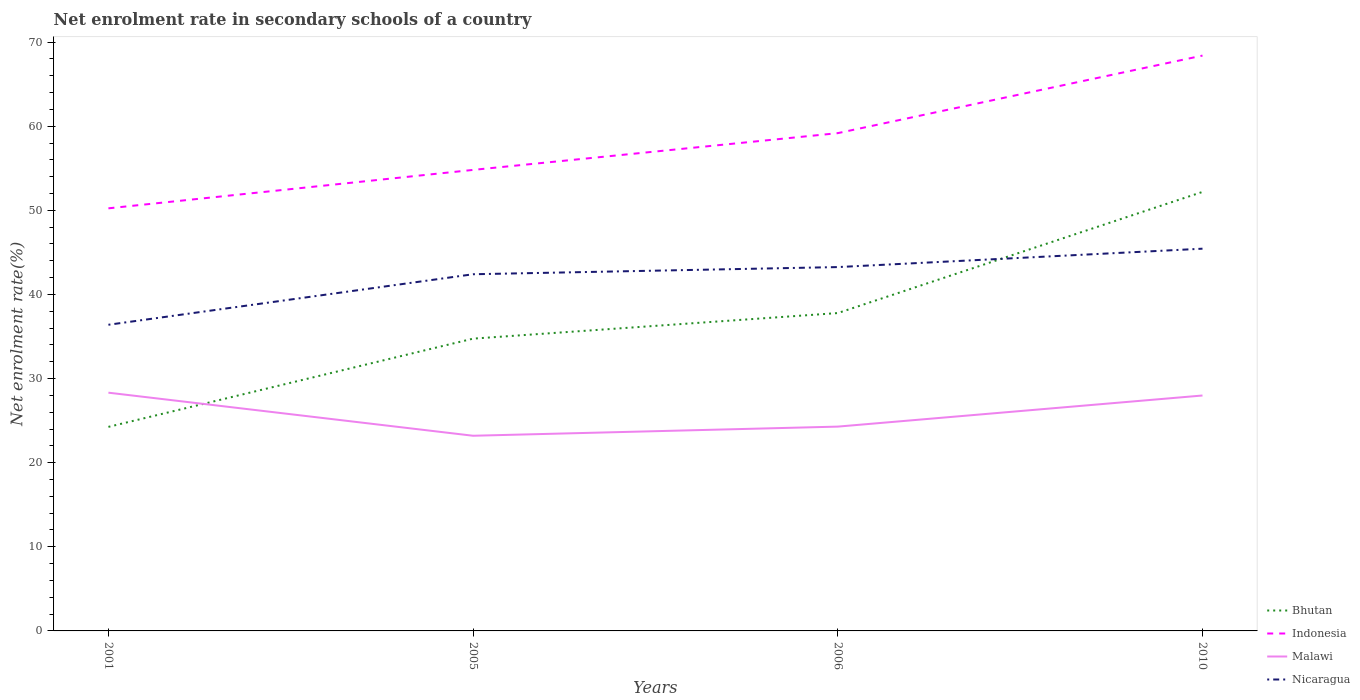Is the number of lines equal to the number of legend labels?
Provide a short and direct response. Yes. Across all years, what is the maximum net enrolment rate in secondary schools in Nicaragua?
Ensure brevity in your answer.  36.39. In which year was the net enrolment rate in secondary schools in Indonesia maximum?
Your answer should be very brief. 2001. What is the total net enrolment rate in secondary schools in Bhutan in the graph?
Your answer should be very brief. -14.4. What is the difference between the highest and the second highest net enrolment rate in secondary schools in Nicaragua?
Your answer should be very brief. 9.04. Is the net enrolment rate in secondary schools in Bhutan strictly greater than the net enrolment rate in secondary schools in Malawi over the years?
Give a very brief answer. No. How many lines are there?
Provide a succinct answer. 4. What is the difference between two consecutive major ticks on the Y-axis?
Make the answer very short. 10. Are the values on the major ticks of Y-axis written in scientific E-notation?
Your answer should be compact. No. Does the graph contain grids?
Offer a terse response. No. Where does the legend appear in the graph?
Provide a succinct answer. Bottom right. What is the title of the graph?
Keep it short and to the point. Net enrolment rate in secondary schools of a country. What is the label or title of the X-axis?
Your answer should be compact. Years. What is the label or title of the Y-axis?
Your answer should be compact. Net enrolment rate(%). What is the Net enrolment rate(%) in Bhutan in 2001?
Ensure brevity in your answer.  24.26. What is the Net enrolment rate(%) in Indonesia in 2001?
Keep it short and to the point. 50.24. What is the Net enrolment rate(%) of Malawi in 2001?
Your response must be concise. 28.32. What is the Net enrolment rate(%) of Nicaragua in 2001?
Provide a succinct answer. 36.39. What is the Net enrolment rate(%) of Bhutan in 2005?
Give a very brief answer. 34.75. What is the Net enrolment rate(%) of Indonesia in 2005?
Provide a succinct answer. 54.8. What is the Net enrolment rate(%) in Malawi in 2005?
Ensure brevity in your answer.  23.2. What is the Net enrolment rate(%) of Nicaragua in 2005?
Offer a very short reply. 42.4. What is the Net enrolment rate(%) in Bhutan in 2006?
Your answer should be very brief. 37.79. What is the Net enrolment rate(%) in Indonesia in 2006?
Give a very brief answer. 59.17. What is the Net enrolment rate(%) of Malawi in 2006?
Offer a terse response. 24.29. What is the Net enrolment rate(%) in Nicaragua in 2006?
Your answer should be compact. 43.25. What is the Net enrolment rate(%) in Bhutan in 2010?
Make the answer very short. 52.19. What is the Net enrolment rate(%) of Indonesia in 2010?
Provide a short and direct response. 68.39. What is the Net enrolment rate(%) of Malawi in 2010?
Make the answer very short. 27.99. What is the Net enrolment rate(%) in Nicaragua in 2010?
Ensure brevity in your answer.  45.44. Across all years, what is the maximum Net enrolment rate(%) of Bhutan?
Keep it short and to the point. 52.19. Across all years, what is the maximum Net enrolment rate(%) in Indonesia?
Your response must be concise. 68.39. Across all years, what is the maximum Net enrolment rate(%) in Malawi?
Make the answer very short. 28.32. Across all years, what is the maximum Net enrolment rate(%) of Nicaragua?
Offer a very short reply. 45.44. Across all years, what is the minimum Net enrolment rate(%) of Bhutan?
Offer a terse response. 24.26. Across all years, what is the minimum Net enrolment rate(%) of Indonesia?
Your answer should be compact. 50.24. Across all years, what is the minimum Net enrolment rate(%) in Malawi?
Your response must be concise. 23.2. Across all years, what is the minimum Net enrolment rate(%) in Nicaragua?
Your response must be concise. 36.39. What is the total Net enrolment rate(%) of Bhutan in the graph?
Offer a very short reply. 148.97. What is the total Net enrolment rate(%) of Indonesia in the graph?
Ensure brevity in your answer.  232.61. What is the total Net enrolment rate(%) of Malawi in the graph?
Offer a terse response. 103.79. What is the total Net enrolment rate(%) of Nicaragua in the graph?
Offer a terse response. 167.48. What is the difference between the Net enrolment rate(%) of Bhutan in 2001 and that in 2005?
Offer a terse response. -10.49. What is the difference between the Net enrolment rate(%) in Indonesia in 2001 and that in 2005?
Make the answer very short. -4.57. What is the difference between the Net enrolment rate(%) in Malawi in 2001 and that in 2005?
Keep it short and to the point. 5.12. What is the difference between the Net enrolment rate(%) of Nicaragua in 2001 and that in 2005?
Give a very brief answer. -6.01. What is the difference between the Net enrolment rate(%) of Bhutan in 2001 and that in 2006?
Ensure brevity in your answer.  -13.53. What is the difference between the Net enrolment rate(%) in Indonesia in 2001 and that in 2006?
Offer a terse response. -8.94. What is the difference between the Net enrolment rate(%) of Malawi in 2001 and that in 2006?
Make the answer very short. 4.03. What is the difference between the Net enrolment rate(%) in Nicaragua in 2001 and that in 2006?
Provide a short and direct response. -6.86. What is the difference between the Net enrolment rate(%) of Bhutan in 2001 and that in 2010?
Your response must be concise. -27.93. What is the difference between the Net enrolment rate(%) in Indonesia in 2001 and that in 2010?
Your answer should be very brief. -18.16. What is the difference between the Net enrolment rate(%) in Malawi in 2001 and that in 2010?
Provide a succinct answer. 0.34. What is the difference between the Net enrolment rate(%) in Nicaragua in 2001 and that in 2010?
Make the answer very short. -9.04. What is the difference between the Net enrolment rate(%) of Bhutan in 2005 and that in 2006?
Your answer should be compact. -3.04. What is the difference between the Net enrolment rate(%) of Indonesia in 2005 and that in 2006?
Provide a short and direct response. -4.37. What is the difference between the Net enrolment rate(%) of Malawi in 2005 and that in 2006?
Provide a short and direct response. -1.09. What is the difference between the Net enrolment rate(%) in Nicaragua in 2005 and that in 2006?
Make the answer very short. -0.85. What is the difference between the Net enrolment rate(%) in Bhutan in 2005 and that in 2010?
Offer a terse response. -17.44. What is the difference between the Net enrolment rate(%) of Indonesia in 2005 and that in 2010?
Offer a very short reply. -13.59. What is the difference between the Net enrolment rate(%) in Malawi in 2005 and that in 2010?
Provide a succinct answer. -4.79. What is the difference between the Net enrolment rate(%) in Nicaragua in 2005 and that in 2010?
Offer a very short reply. -3.04. What is the difference between the Net enrolment rate(%) in Bhutan in 2006 and that in 2010?
Offer a very short reply. -14.4. What is the difference between the Net enrolment rate(%) of Indonesia in 2006 and that in 2010?
Ensure brevity in your answer.  -9.22. What is the difference between the Net enrolment rate(%) of Malawi in 2006 and that in 2010?
Your answer should be compact. -3.7. What is the difference between the Net enrolment rate(%) of Nicaragua in 2006 and that in 2010?
Your response must be concise. -2.19. What is the difference between the Net enrolment rate(%) in Bhutan in 2001 and the Net enrolment rate(%) in Indonesia in 2005?
Ensure brevity in your answer.  -30.55. What is the difference between the Net enrolment rate(%) of Bhutan in 2001 and the Net enrolment rate(%) of Malawi in 2005?
Offer a very short reply. 1.06. What is the difference between the Net enrolment rate(%) in Bhutan in 2001 and the Net enrolment rate(%) in Nicaragua in 2005?
Ensure brevity in your answer.  -18.14. What is the difference between the Net enrolment rate(%) in Indonesia in 2001 and the Net enrolment rate(%) in Malawi in 2005?
Offer a very short reply. 27.04. What is the difference between the Net enrolment rate(%) of Indonesia in 2001 and the Net enrolment rate(%) of Nicaragua in 2005?
Ensure brevity in your answer.  7.84. What is the difference between the Net enrolment rate(%) of Malawi in 2001 and the Net enrolment rate(%) of Nicaragua in 2005?
Offer a very short reply. -14.08. What is the difference between the Net enrolment rate(%) in Bhutan in 2001 and the Net enrolment rate(%) in Indonesia in 2006?
Give a very brief answer. -34.92. What is the difference between the Net enrolment rate(%) of Bhutan in 2001 and the Net enrolment rate(%) of Malawi in 2006?
Your answer should be compact. -0.03. What is the difference between the Net enrolment rate(%) of Bhutan in 2001 and the Net enrolment rate(%) of Nicaragua in 2006?
Make the answer very short. -19. What is the difference between the Net enrolment rate(%) in Indonesia in 2001 and the Net enrolment rate(%) in Malawi in 2006?
Offer a terse response. 25.95. What is the difference between the Net enrolment rate(%) in Indonesia in 2001 and the Net enrolment rate(%) in Nicaragua in 2006?
Provide a short and direct response. 6.98. What is the difference between the Net enrolment rate(%) of Malawi in 2001 and the Net enrolment rate(%) of Nicaragua in 2006?
Provide a short and direct response. -14.93. What is the difference between the Net enrolment rate(%) in Bhutan in 2001 and the Net enrolment rate(%) in Indonesia in 2010?
Make the answer very short. -44.14. What is the difference between the Net enrolment rate(%) in Bhutan in 2001 and the Net enrolment rate(%) in Malawi in 2010?
Keep it short and to the point. -3.73. What is the difference between the Net enrolment rate(%) in Bhutan in 2001 and the Net enrolment rate(%) in Nicaragua in 2010?
Provide a succinct answer. -21.18. What is the difference between the Net enrolment rate(%) in Indonesia in 2001 and the Net enrolment rate(%) in Malawi in 2010?
Give a very brief answer. 22.25. What is the difference between the Net enrolment rate(%) in Indonesia in 2001 and the Net enrolment rate(%) in Nicaragua in 2010?
Give a very brief answer. 4.8. What is the difference between the Net enrolment rate(%) in Malawi in 2001 and the Net enrolment rate(%) in Nicaragua in 2010?
Offer a very short reply. -17.12. What is the difference between the Net enrolment rate(%) in Bhutan in 2005 and the Net enrolment rate(%) in Indonesia in 2006?
Provide a succinct answer. -24.43. What is the difference between the Net enrolment rate(%) in Bhutan in 2005 and the Net enrolment rate(%) in Malawi in 2006?
Provide a succinct answer. 10.46. What is the difference between the Net enrolment rate(%) of Bhutan in 2005 and the Net enrolment rate(%) of Nicaragua in 2006?
Provide a short and direct response. -8.51. What is the difference between the Net enrolment rate(%) of Indonesia in 2005 and the Net enrolment rate(%) of Malawi in 2006?
Your answer should be compact. 30.52. What is the difference between the Net enrolment rate(%) in Indonesia in 2005 and the Net enrolment rate(%) in Nicaragua in 2006?
Make the answer very short. 11.55. What is the difference between the Net enrolment rate(%) of Malawi in 2005 and the Net enrolment rate(%) of Nicaragua in 2006?
Give a very brief answer. -20.05. What is the difference between the Net enrolment rate(%) of Bhutan in 2005 and the Net enrolment rate(%) of Indonesia in 2010?
Offer a very short reply. -33.65. What is the difference between the Net enrolment rate(%) of Bhutan in 2005 and the Net enrolment rate(%) of Malawi in 2010?
Ensure brevity in your answer.  6.76. What is the difference between the Net enrolment rate(%) in Bhutan in 2005 and the Net enrolment rate(%) in Nicaragua in 2010?
Make the answer very short. -10.69. What is the difference between the Net enrolment rate(%) in Indonesia in 2005 and the Net enrolment rate(%) in Malawi in 2010?
Ensure brevity in your answer.  26.82. What is the difference between the Net enrolment rate(%) in Indonesia in 2005 and the Net enrolment rate(%) in Nicaragua in 2010?
Provide a succinct answer. 9.37. What is the difference between the Net enrolment rate(%) of Malawi in 2005 and the Net enrolment rate(%) of Nicaragua in 2010?
Your answer should be very brief. -22.24. What is the difference between the Net enrolment rate(%) in Bhutan in 2006 and the Net enrolment rate(%) in Indonesia in 2010?
Your answer should be very brief. -30.61. What is the difference between the Net enrolment rate(%) of Bhutan in 2006 and the Net enrolment rate(%) of Malawi in 2010?
Provide a succinct answer. 9.8. What is the difference between the Net enrolment rate(%) in Bhutan in 2006 and the Net enrolment rate(%) in Nicaragua in 2010?
Your response must be concise. -7.65. What is the difference between the Net enrolment rate(%) in Indonesia in 2006 and the Net enrolment rate(%) in Malawi in 2010?
Provide a short and direct response. 31.19. What is the difference between the Net enrolment rate(%) of Indonesia in 2006 and the Net enrolment rate(%) of Nicaragua in 2010?
Give a very brief answer. 13.74. What is the difference between the Net enrolment rate(%) of Malawi in 2006 and the Net enrolment rate(%) of Nicaragua in 2010?
Your answer should be very brief. -21.15. What is the average Net enrolment rate(%) in Bhutan per year?
Your answer should be very brief. 37.24. What is the average Net enrolment rate(%) in Indonesia per year?
Give a very brief answer. 58.15. What is the average Net enrolment rate(%) in Malawi per year?
Make the answer very short. 25.95. What is the average Net enrolment rate(%) in Nicaragua per year?
Provide a short and direct response. 41.87. In the year 2001, what is the difference between the Net enrolment rate(%) in Bhutan and Net enrolment rate(%) in Indonesia?
Provide a short and direct response. -25.98. In the year 2001, what is the difference between the Net enrolment rate(%) of Bhutan and Net enrolment rate(%) of Malawi?
Your answer should be very brief. -4.06. In the year 2001, what is the difference between the Net enrolment rate(%) of Bhutan and Net enrolment rate(%) of Nicaragua?
Give a very brief answer. -12.14. In the year 2001, what is the difference between the Net enrolment rate(%) in Indonesia and Net enrolment rate(%) in Malawi?
Keep it short and to the point. 21.91. In the year 2001, what is the difference between the Net enrolment rate(%) in Indonesia and Net enrolment rate(%) in Nicaragua?
Provide a succinct answer. 13.84. In the year 2001, what is the difference between the Net enrolment rate(%) of Malawi and Net enrolment rate(%) of Nicaragua?
Make the answer very short. -8.07. In the year 2005, what is the difference between the Net enrolment rate(%) in Bhutan and Net enrolment rate(%) in Indonesia?
Provide a short and direct response. -20.06. In the year 2005, what is the difference between the Net enrolment rate(%) in Bhutan and Net enrolment rate(%) in Malawi?
Provide a short and direct response. 11.55. In the year 2005, what is the difference between the Net enrolment rate(%) of Bhutan and Net enrolment rate(%) of Nicaragua?
Give a very brief answer. -7.65. In the year 2005, what is the difference between the Net enrolment rate(%) of Indonesia and Net enrolment rate(%) of Malawi?
Your answer should be compact. 31.6. In the year 2005, what is the difference between the Net enrolment rate(%) in Indonesia and Net enrolment rate(%) in Nicaragua?
Make the answer very short. 12.4. In the year 2005, what is the difference between the Net enrolment rate(%) of Malawi and Net enrolment rate(%) of Nicaragua?
Give a very brief answer. -19.2. In the year 2006, what is the difference between the Net enrolment rate(%) of Bhutan and Net enrolment rate(%) of Indonesia?
Give a very brief answer. -21.39. In the year 2006, what is the difference between the Net enrolment rate(%) in Bhutan and Net enrolment rate(%) in Malawi?
Offer a very short reply. 13.5. In the year 2006, what is the difference between the Net enrolment rate(%) of Bhutan and Net enrolment rate(%) of Nicaragua?
Provide a short and direct response. -5.47. In the year 2006, what is the difference between the Net enrolment rate(%) of Indonesia and Net enrolment rate(%) of Malawi?
Make the answer very short. 34.89. In the year 2006, what is the difference between the Net enrolment rate(%) in Indonesia and Net enrolment rate(%) in Nicaragua?
Give a very brief answer. 15.92. In the year 2006, what is the difference between the Net enrolment rate(%) of Malawi and Net enrolment rate(%) of Nicaragua?
Your answer should be very brief. -18.96. In the year 2010, what is the difference between the Net enrolment rate(%) of Bhutan and Net enrolment rate(%) of Indonesia?
Ensure brevity in your answer.  -16.21. In the year 2010, what is the difference between the Net enrolment rate(%) in Bhutan and Net enrolment rate(%) in Malawi?
Offer a very short reply. 24.2. In the year 2010, what is the difference between the Net enrolment rate(%) of Bhutan and Net enrolment rate(%) of Nicaragua?
Provide a succinct answer. 6.75. In the year 2010, what is the difference between the Net enrolment rate(%) in Indonesia and Net enrolment rate(%) in Malawi?
Your response must be concise. 40.41. In the year 2010, what is the difference between the Net enrolment rate(%) in Indonesia and Net enrolment rate(%) in Nicaragua?
Offer a very short reply. 22.96. In the year 2010, what is the difference between the Net enrolment rate(%) of Malawi and Net enrolment rate(%) of Nicaragua?
Your response must be concise. -17.45. What is the ratio of the Net enrolment rate(%) in Bhutan in 2001 to that in 2005?
Keep it short and to the point. 0.7. What is the ratio of the Net enrolment rate(%) of Indonesia in 2001 to that in 2005?
Offer a very short reply. 0.92. What is the ratio of the Net enrolment rate(%) of Malawi in 2001 to that in 2005?
Provide a short and direct response. 1.22. What is the ratio of the Net enrolment rate(%) of Nicaragua in 2001 to that in 2005?
Offer a very short reply. 0.86. What is the ratio of the Net enrolment rate(%) of Bhutan in 2001 to that in 2006?
Your answer should be very brief. 0.64. What is the ratio of the Net enrolment rate(%) of Indonesia in 2001 to that in 2006?
Your response must be concise. 0.85. What is the ratio of the Net enrolment rate(%) in Malawi in 2001 to that in 2006?
Your response must be concise. 1.17. What is the ratio of the Net enrolment rate(%) in Nicaragua in 2001 to that in 2006?
Provide a succinct answer. 0.84. What is the ratio of the Net enrolment rate(%) of Bhutan in 2001 to that in 2010?
Provide a succinct answer. 0.46. What is the ratio of the Net enrolment rate(%) of Indonesia in 2001 to that in 2010?
Provide a short and direct response. 0.73. What is the ratio of the Net enrolment rate(%) in Nicaragua in 2001 to that in 2010?
Your answer should be very brief. 0.8. What is the ratio of the Net enrolment rate(%) of Bhutan in 2005 to that in 2006?
Give a very brief answer. 0.92. What is the ratio of the Net enrolment rate(%) of Indonesia in 2005 to that in 2006?
Provide a short and direct response. 0.93. What is the ratio of the Net enrolment rate(%) of Malawi in 2005 to that in 2006?
Give a very brief answer. 0.96. What is the ratio of the Net enrolment rate(%) in Nicaragua in 2005 to that in 2006?
Keep it short and to the point. 0.98. What is the ratio of the Net enrolment rate(%) in Bhutan in 2005 to that in 2010?
Your answer should be very brief. 0.67. What is the ratio of the Net enrolment rate(%) of Indonesia in 2005 to that in 2010?
Make the answer very short. 0.8. What is the ratio of the Net enrolment rate(%) in Malawi in 2005 to that in 2010?
Offer a very short reply. 0.83. What is the ratio of the Net enrolment rate(%) in Nicaragua in 2005 to that in 2010?
Keep it short and to the point. 0.93. What is the ratio of the Net enrolment rate(%) of Bhutan in 2006 to that in 2010?
Provide a short and direct response. 0.72. What is the ratio of the Net enrolment rate(%) of Indonesia in 2006 to that in 2010?
Offer a very short reply. 0.87. What is the ratio of the Net enrolment rate(%) in Malawi in 2006 to that in 2010?
Your response must be concise. 0.87. What is the ratio of the Net enrolment rate(%) of Nicaragua in 2006 to that in 2010?
Provide a short and direct response. 0.95. What is the difference between the highest and the second highest Net enrolment rate(%) of Bhutan?
Your answer should be compact. 14.4. What is the difference between the highest and the second highest Net enrolment rate(%) of Indonesia?
Provide a short and direct response. 9.22. What is the difference between the highest and the second highest Net enrolment rate(%) of Malawi?
Provide a short and direct response. 0.34. What is the difference between the highest and the second highest Net enrolment rate(%) of Nicaragua?
Ensure brevity in your answer.  2.19. What is the difference between the highest and the lowest Net enrolment rate(%) in Bhutan?
Give a very brief answer. 27.93. What is the difference between the highest and the lowest Net enrolment rate(%) of Indonesia?
Give a very brief answer. 18.16. What is the difference between the highest and the lowest Net enrolment rate(%) in Malawi?
Ensure brevity in your answer.  5.12. What is the difference between the highest and the lowest Net enrolment rate(%) of Nicaragua?
Your answer should be very brief. 9.04. 